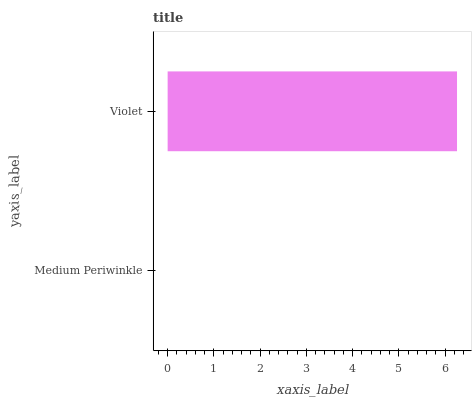Is Medium Periwinkle the minimum?
Answer yes or no. Yes. Is Violet the maximum?
Answer yes or no. Yes. Is Violet the minimum?
Answer yes or no. No. Is Violet greater than Medium Periwinkle?
Answer yes or no. Yes. Is Medium Periwinkle less than Violet?
Answer yes or no. Yes. Is Medium Periwinkle greater than Violet?
Answer yes or no. No. Is Violet less than Medium Periwinkle?
Answer yes or no. No. Is Violet the high median?
Answer yes or no. Yes. Is Medium Periwinkle the low median?
Answer yes or no. Yes. Is Medium Periwinkle the high median?
Answer yes or no. No. Is Violet the low median?
Answer yes or no. No. 